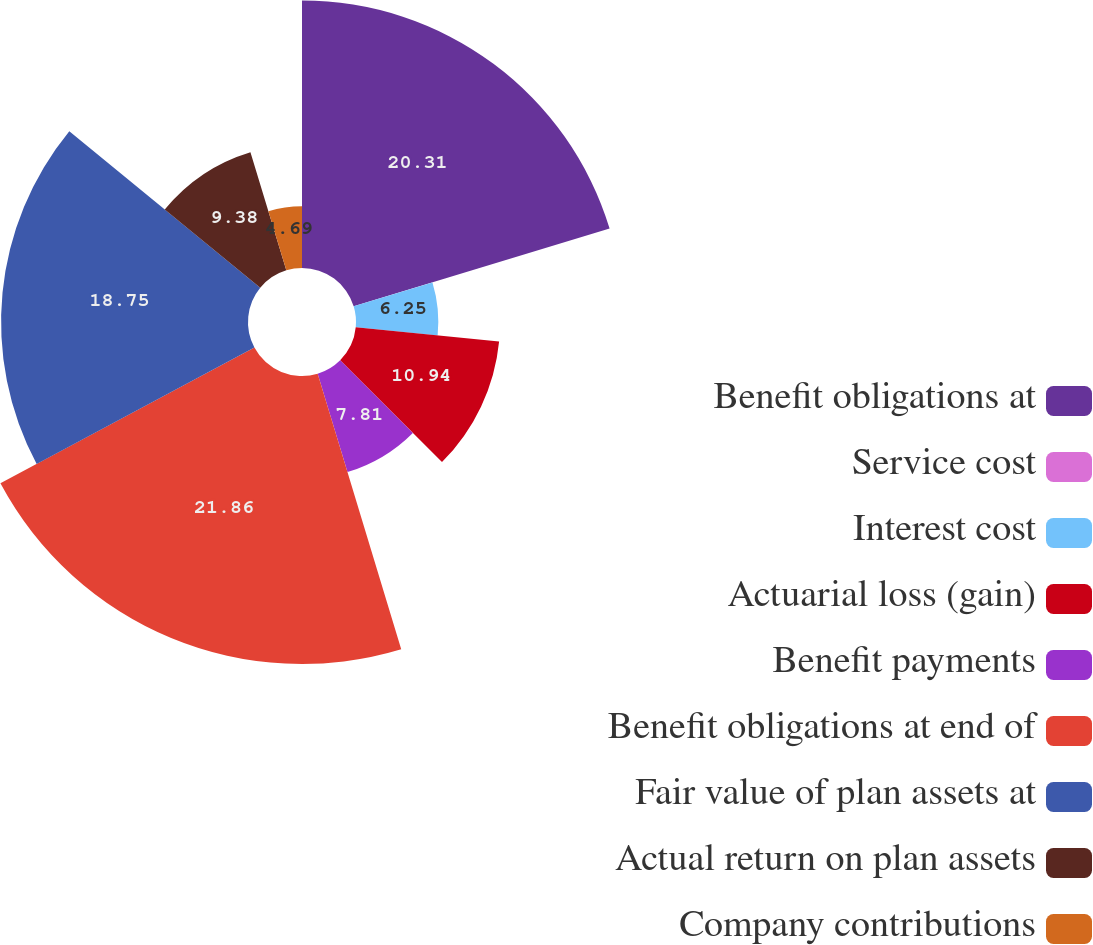Convert chart. <chart><loc_0><loc_0><loc_500><loc_500><pie_chart><fcel>Benefit obligations at<fcel>Service cost<fcel>Interest cost<fcel>Actuarial loss (gain)<fcel>Benefit payments<fcel>Benefit obligations at end of<fcel>Fair value of plan assets at<fcel>Actual return on plan assets<fcel>Company contributions<nl><fcel>20.31%<fcel>0.01%<fcel>6.25%<fcel>10.94%<fcel>7.81%<fcel>21.87%<fcel>18.75%<fcel>9.38%<fcel>4.69%<nl></chart> 